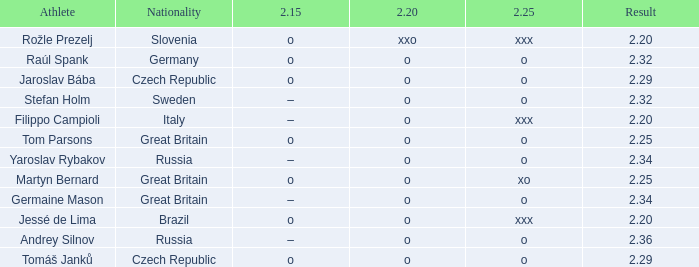Which athlete from Germany has 2.20 of O and a 2.25 of O? Raúl Spank. 